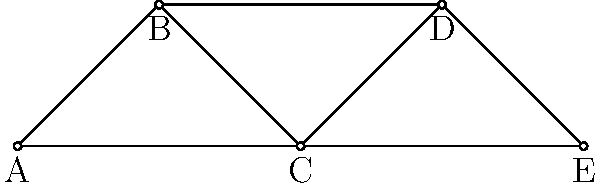In the network diagram representing a political campaign's communication structure, how many nodes need to be removed to disconnect node A from node E completely? Justify your answer considering the potential implications for information flow in the campaign. To answer this question, we need to analyze the connectivity between nodes A and E:

1. First, identify all possible paths from A to E:
   - Path 1: A → B → C → E
   - Path 2: A → B → D → E
   - Path 3: A → C → D → E
   - Path 4: A → C → E

2. To disconnect A from E, we need to break all these paths.

3. Observe that node C appears in three out of four paths. Removing C would break paths 1, 3, and 4.

4. After removing C, only path 2 (A → B → D → E) remains.

5. To break this final path, we need to remove either B or D.

6. Therefore, the minimum number of nodes to remove is 2 (C and either B or D).

Implications for the campaign:
- Removing these nodes would significantly disrupt information flow.
- It highlights potential vulnerabilities in the communication structure.
- The campaign might want to create additional connections to improve resilience.

This analysis demonstrates the importance of network redundancy in maintaining robust communication channels within a political campaign.
Answer: 2 nodes 